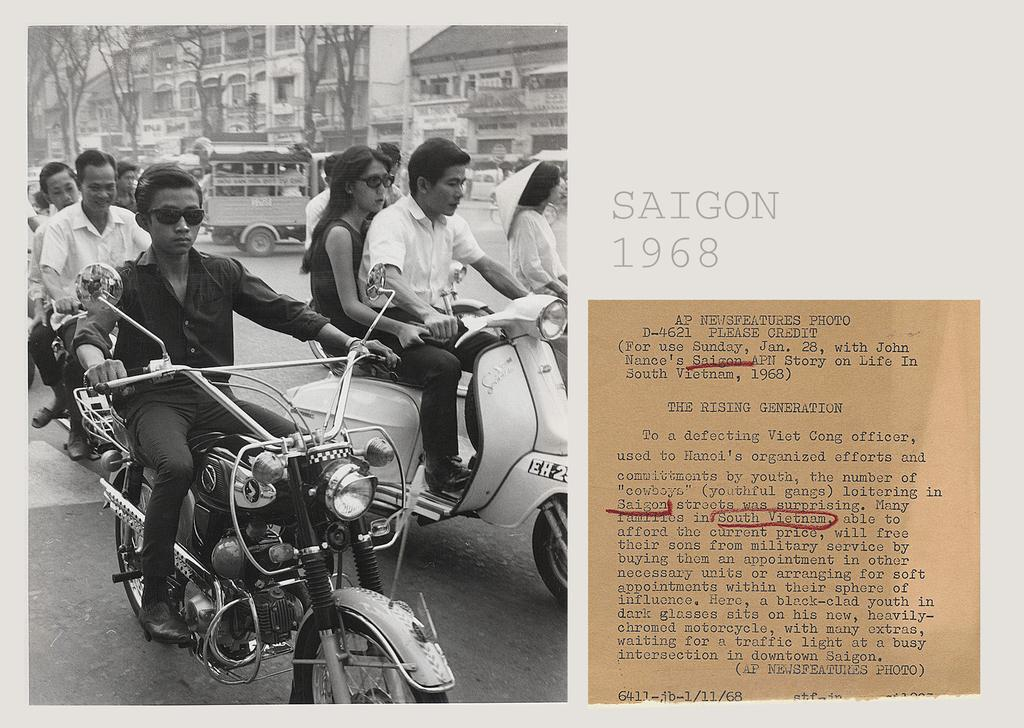What is the color scheme of the image? The image is black and white. What is happening on the road in the image? There are persons riding vehicles on the road. What can be seen in the background of the image? There are buildings and trees in the background of the image. Can you describe any additional objects in the image? Yes, there is a paper note visible in the image. How many cats can be seen climbing the slope in the image? There are no cats or slopes present in the image. 